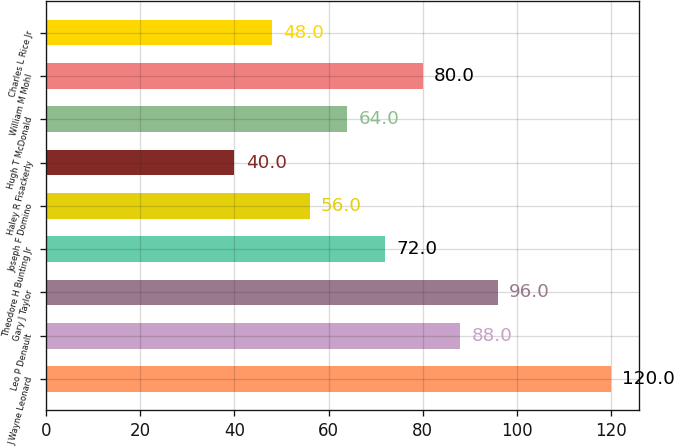Convert chart to OTSL. <chart><loc_0><loc_0><loc_500><loc_500><bar_chart><fcel>J Wayne Leonard<fcel>Leo P Denault<fcel>Gary J Taylor<fcel>Theodore H Bunting Jr<fcel>Joseph F Domino<fcel>Haley R Fisackerly<fcel>Hugh T McDonald<fcel>William M Mohl<fcel>Charles L Rice Jr<nl><fcel>120<fcel>88<fcel>96<fcel>72<fcel>56<fcel>40<fcel>64<fcel>80<fcel>48<nl></chart> 